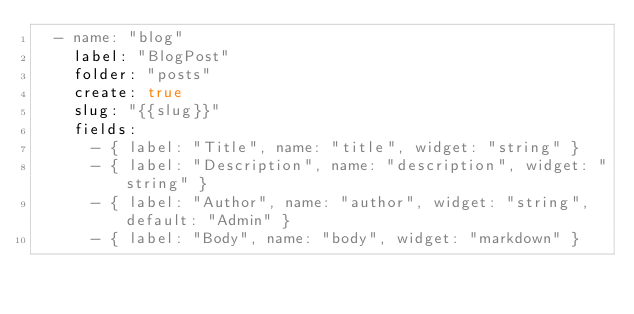<code> <loc_0><loc_0><loc_500><loc_500><_YAML_>  - name: "blog"
    label: "BlogPost"
    folder: "posts"
    create: true
    slug: "{{slug}}"
    fields:
      - { label: "Title", name: "title", widget: "string" }
      - { label: "Description", name: "description", widget: "string" }
      - { label: "Author", name: "author", widget: "string", default: "Admin" }
      - { label: "Body", name: "body", widget: "markdown" }
</code> 